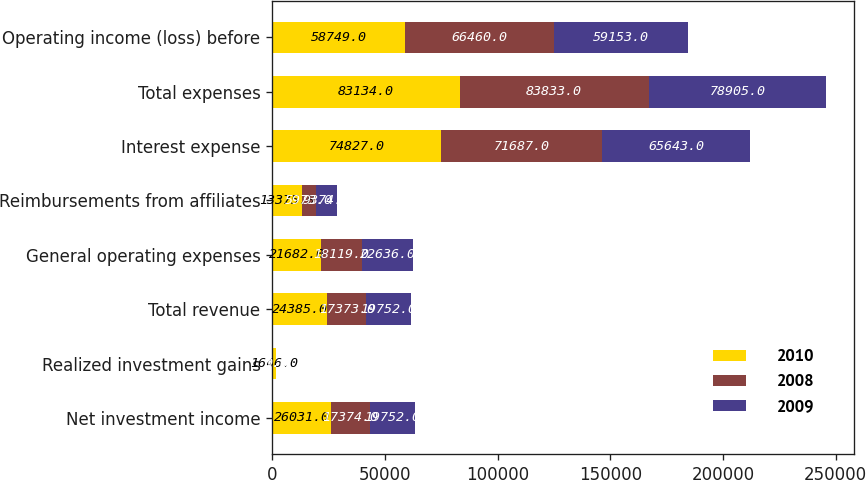Convert chart. <chart><loc_0><loc_0><loc_500><loc_500><stacked_bar_chart><ecel><fcel>Net investment income<fcel>Realized investment gains<fcel>Total revenue<fcel>General operating expenses<fcel>Reimbursements from affiliates<fcel>Interest expense<fcel>Total expenses<fcel>Operating income (loss) before<nl><fcel>2010<fcel>26031<fcel>1646<fcel>24385<fcel>21682<fcel>13375<fcel>74827<fcel>83134<fcel>58749<nl><fcel>2008<fcel>17374<fcel>1<fcel>17373<fcel>18119<fcel>5973<fcel>71687<fcel>83833<fcel>66460<nl><fcel>2009<fcel>19752<fcel>0<fcel>19752<fcel>22636<fcel>9374<fcel>65643<fcel>78905<fcel>59153<nl></chart> 